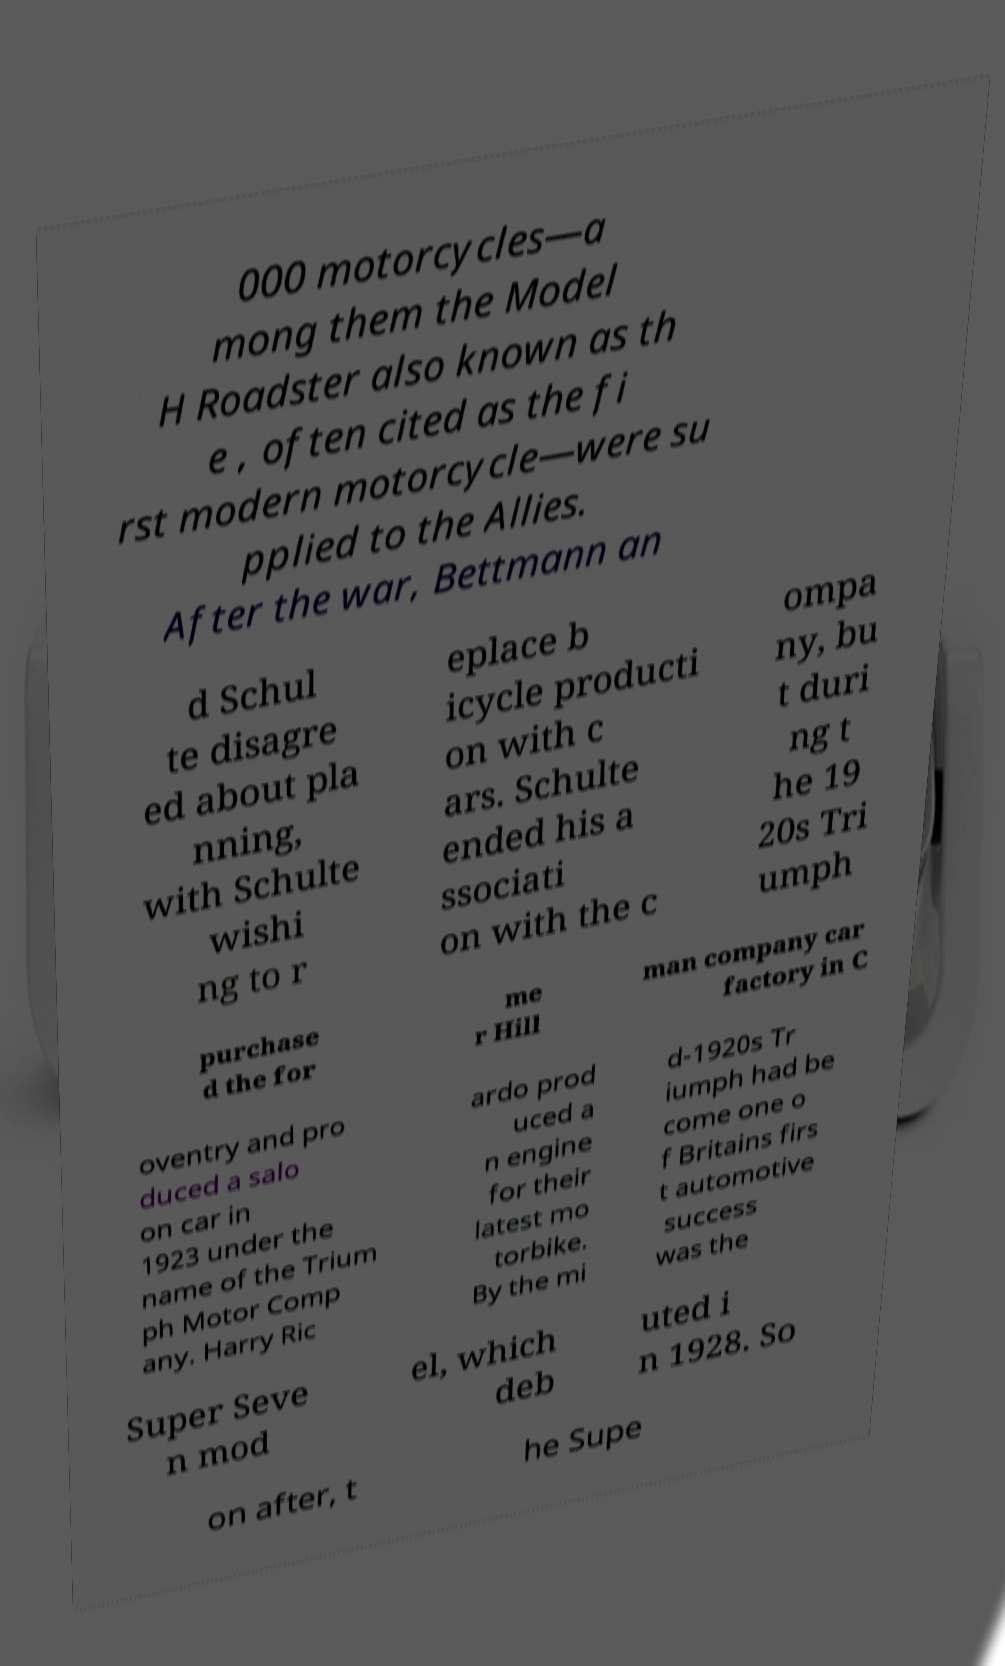What messages or text are displayed in this image? I need them in a readable, typed format. 000 motorcycles—a mong them the Model H Roadster also known as th e , often cited as the fi rst modern motorcycle—were su pplied to the Allies. After the war, Bettmann an d Schul te disagre ed about pla nning, with Schulte wishi ng to r eplace b icycle producti on with c ars. Schulte ended his a ssociati on with the c ompa ny, bu t duri ng t he 19 20s Tri umph purchase d the for me r Hill man company car factory in C oventry and pro duced a salo on car in 1923 under the name of the Trium ph Motor Comp any. Harry Ric ardo prod uced a n engine for their latest mo torbike. By the mi d-1920s Tr iumph had be come one o f Britains firs t automotive success was the Super Seve n mod el, which deb uted i n 1928. So on after, t he Supe 